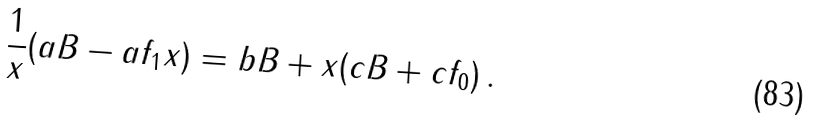Convert formula to latex. <formula><loc_0><loc_0><loc_500><loc_500>\frac { 1 } { x } ( a B - a f _ { 1 } x ) = b B + x ( c B + c f _ { 0 } ) \, .</formula> 